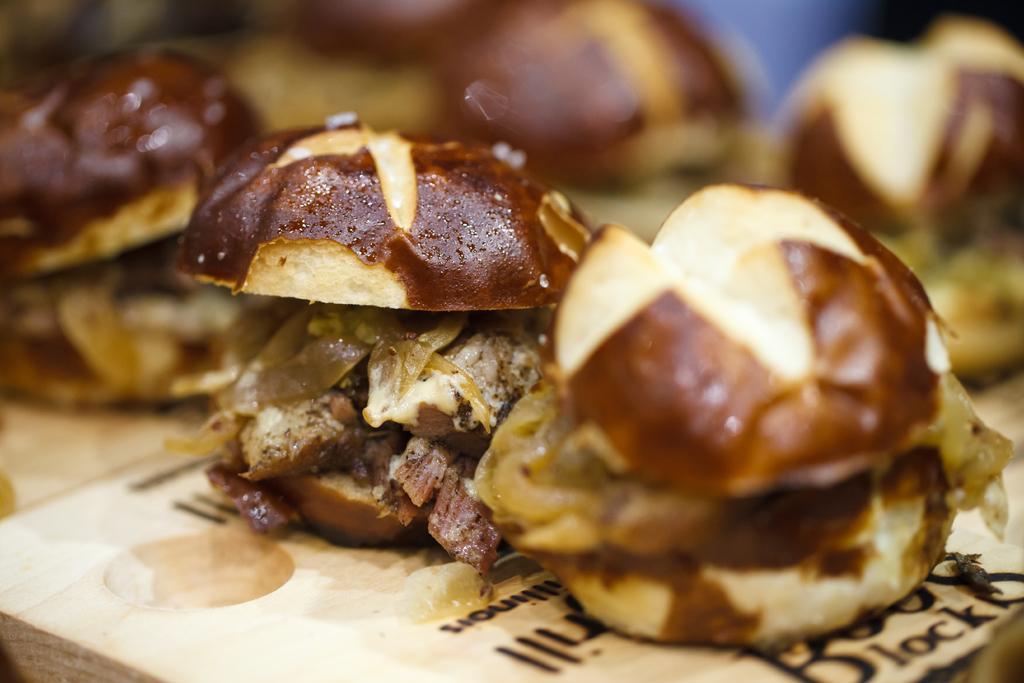How would you summarize this image in a sentence or two? In this image in the foreground there are some burgers, at the bottom there is some object and it looks like a plate and there is blurry background. 